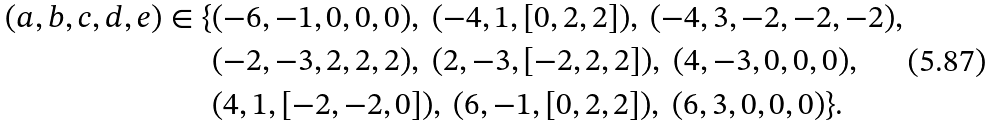<formula> <loc_0><loc_0><loc_500><loc_500>( a , b , c , d , e ) \in \{ & ( - 6 , - 1 , 0 , 0 , 0 ) , \ ( - 4 , 1 , [ 0 , 2 , 2 ] ) , \ ( - 4 , 3 , - 2 , - 2 , - 2 ) , \\ & ( - 2 , - 3 , 2 , 2 , 2 ) , \ ( 2 , - 3 , [ - 2 , 2 , 2 ] ) , \ ( 4 , - 3 , 0 , 0 , 0 ) , \\ & ( 4 , 1 , [ - 2 , - 2 , 0 ] ) , \ ( 6 , - 1 , [ 0 , 2 , 2 ] ) , \ ( 6 , 3 , 0 , 0 , 0 ) \} .</formula> 